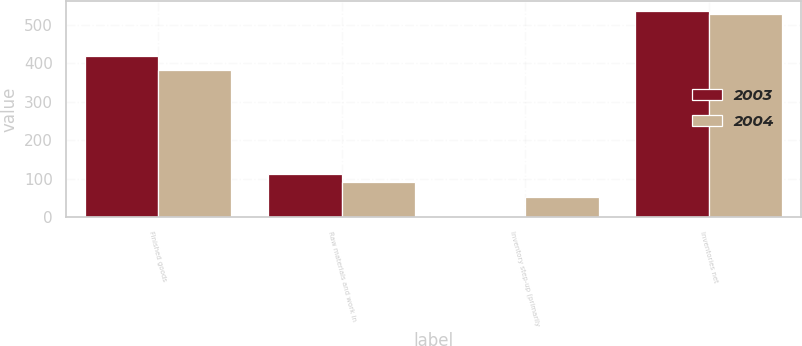Convert chart. <chart><loc_0><loc_0><loc_500><loc_500><stacked_bar_chart><ecel><fcel>Finished goods<fcel>Raw materials and work in<fcel>Inventory step-up (primarily<fcel>Inventories net<nl><fcel>2003<fcel>420.5<fcel>112.2<fcel>3.3<fcel>536<nl><fcel>2004<fcel>384.3<fcel>90.8<fcel>52.6<fcel>527.7<nl></chart> 